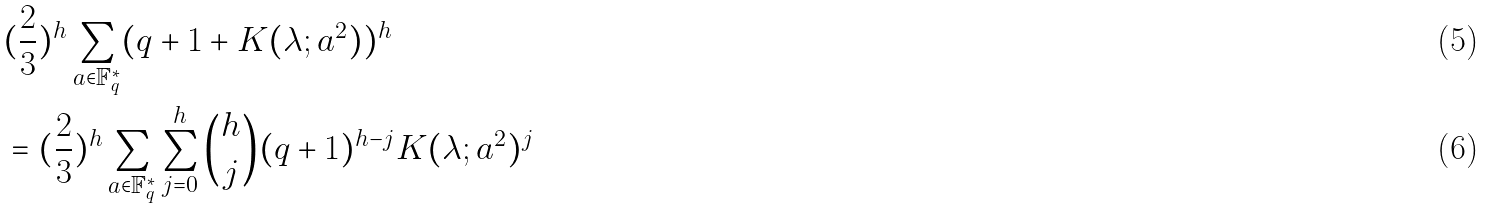<formula> <loc_0><loc_0><loc_500><loc_500>& ( \frac { 2 } { 3 } ) ^ { h } \sum _ { a \in \mathbb { F } _ { q } ^ { * } } ( q + 1 + K ( \lambda ; a ^ { 2 } ) ) ^ { h } \\ & = ( \frac { 2 } { 3 } ) ^ { h } \sum _ { a \in \mathbb { F } _ { q } ^ { * } } \sum _ { j = 0 } ^ { h } { \binom { h } { j } } ( q + 1 ) ^ { h - j } K ( \lambda ; a ^ { 2 } ) ^ { j }</formula> 